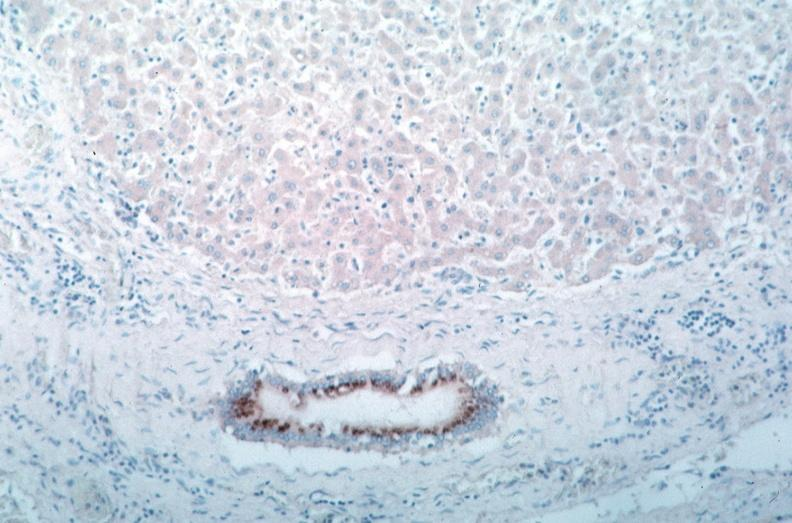what is rocky mountain spotted?
Answer the question using a single word or phrase. Fever 